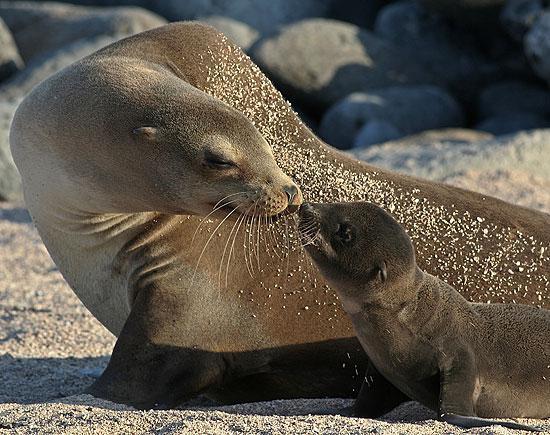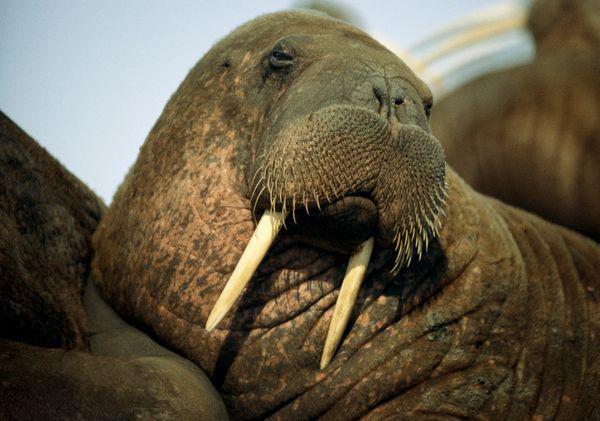The first image is the image on the left, the second image is the image on the right. Given the left and right images, does the statement "There are no baby animals in at least one of the images." hold true? Answer yes or no. Yes. The first image is the image on the left, the second image is the image on the right. For the images shown, is this caption "One image shows exactly three seals clustered together, in the foreground." true? Answer yes or no. No. 